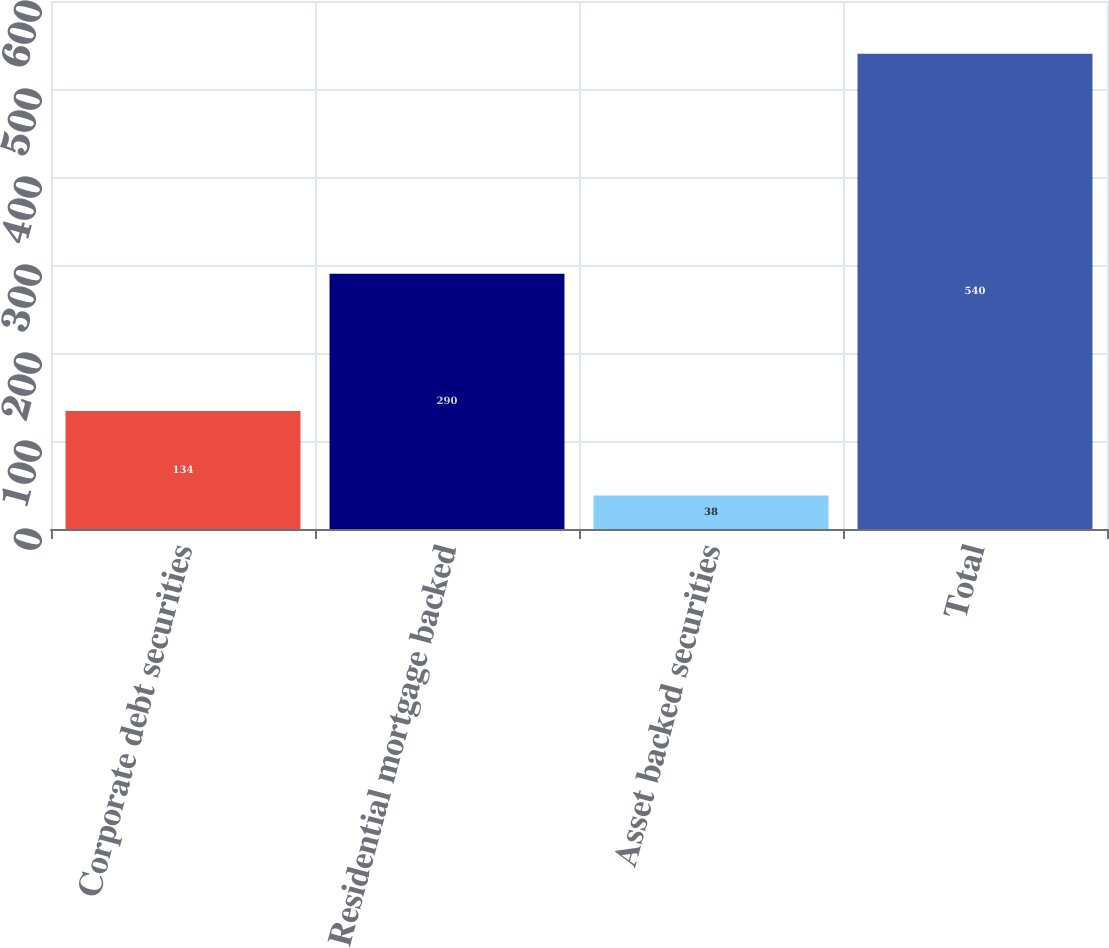Convert chart to OTSL. <chart><loc_0><loc_0><loc_500><loc_500><bar_chart><fcel>Corporate debt securities<fcel>Residential mortgage backed<fcel>Asset backed securities<fcel>Total<nl><fcel>134<fcel>290<fcel>38<fcel>540<nl></chart> 